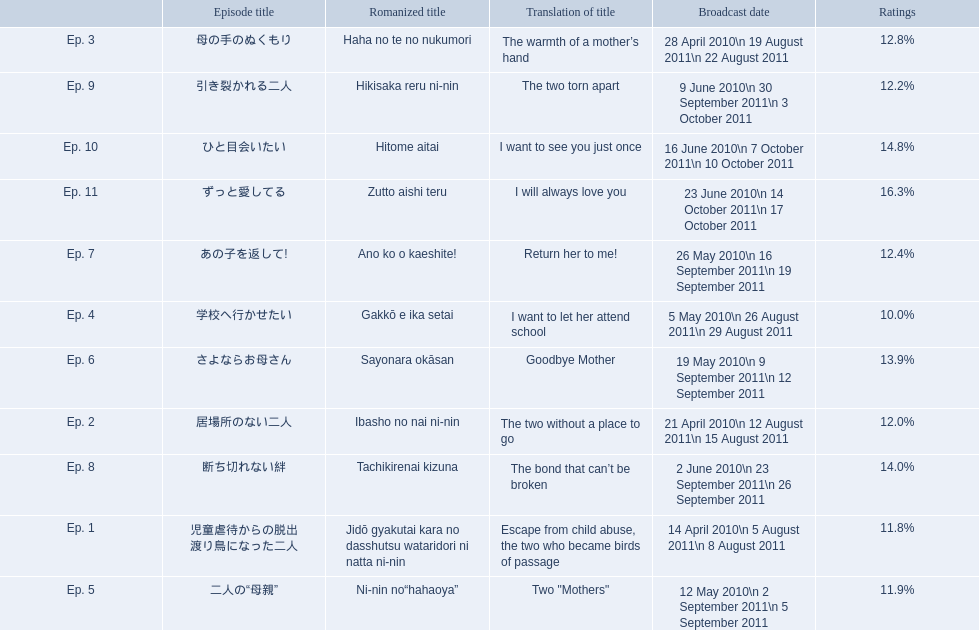What are the episode numbers? Ep. 1, Ep. 2, Ep. 3, Ep. 4, Ep. 5, Ep. 6, Ep. 7, Ep. 8, Ep. 9, Ep. 10, Ep. 11. What was the percentage of total ratings for episode 8? 14.0%. 